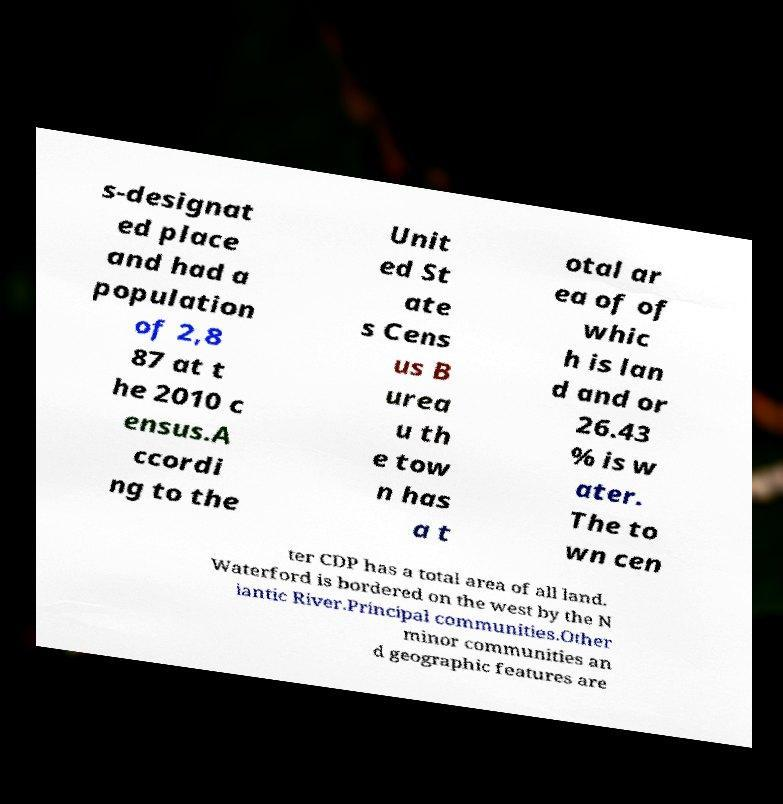Can you read and provide the text displayed in the image?This photo seems to have some interesting text. Can you extract and type it out for me? s-designat ed place and had a population of 2,8 87 at t he 2010 c ensus.A ccordi ng to the Unit ed St ate s Cens us B urea u th e tow n has a t otal ar ea of of whic h is lan d and or 26.43 % is w ater. The to wn cen ter CDP has a total area of all land. Waterford is bordered on the west by the N iantic River.Principal communities.Other minor communities an d geographic features are 